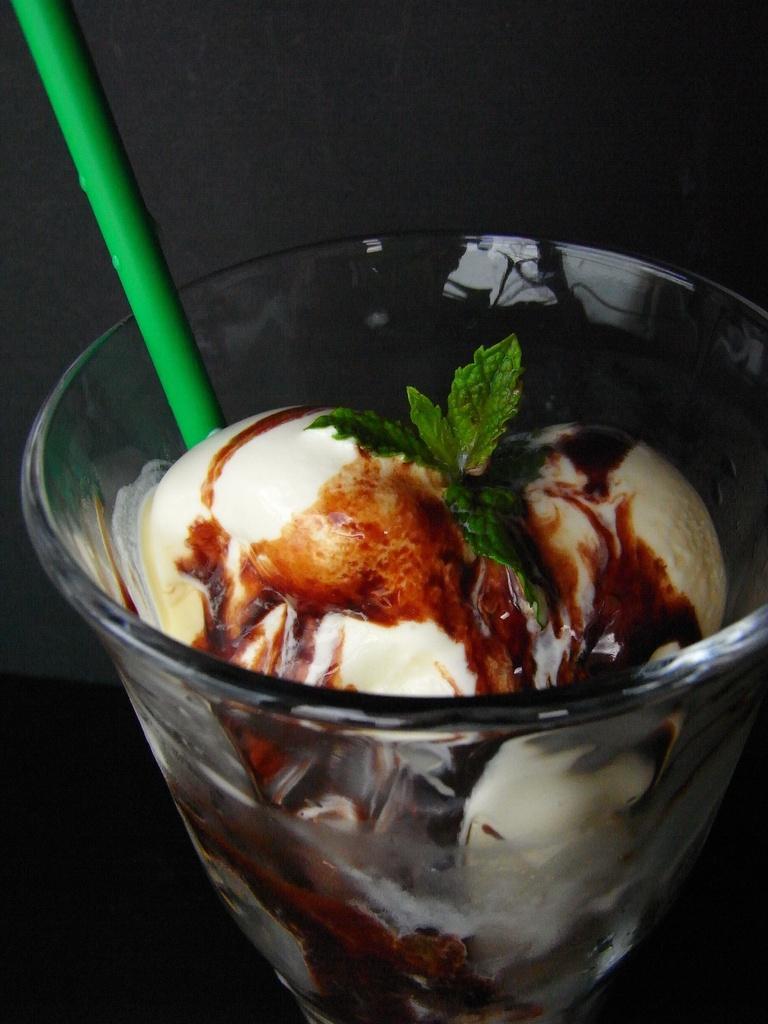How would you summarize this image in a sentence or two? In this image we can see a glass with ice cream. On that there are mint leaves and also there is a straw. In the background it is dark. 